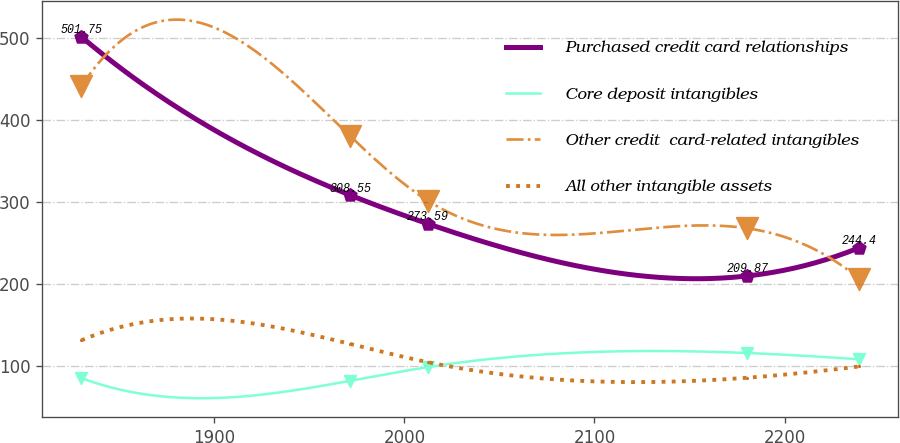Convert chart to OTSL. <chart><loc_0><loc_0><loc_500><loc_500><line_chart><ecel><fcel>Purchased credit card relationships<fcel>Core deposit intangibles<fcel>Other credit  card-related intangibles<fcel>All other intangible assets<nl><fcel>1829.93<fcel>501.75<fcel>85.35<fcel>441.12<fcel>131.26<nl><fcel>1971.39<fcel>308.55<fcel>81.96<fcel>380.63<fcel>127.02<nl><fcel>2012.33<fcel>273.59<fcel>98.73<fcel>301.65<fcel>104.69<nl><fcel>2180.37<fcel>209.87<fcel>115.9<fcel>268.02<fcel>85.72<nl><fcel>2239.36<fcel>244.4<fcel>108.22<fcel>206.18<fcel>99.51<nl></chart> 